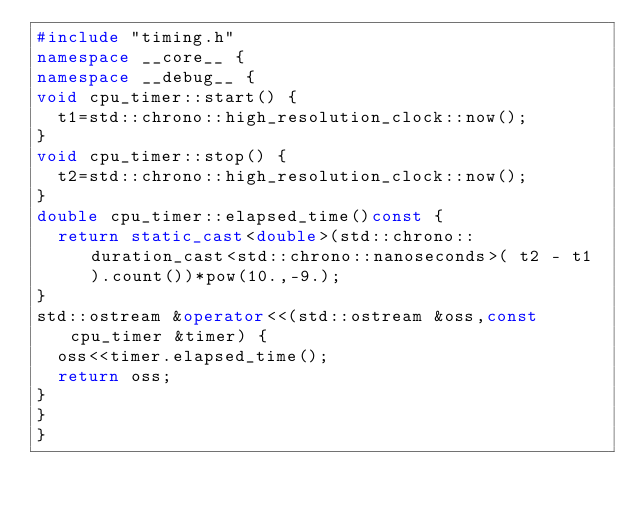Convert code to text. <code><loc_0><loc_0><loc_500><loc_500><_C++_>#include "timing.h"
namespace __core__ {
namespace __debug__ {
void cpu_timer::start() {
	t1=std::chrono::high_resolution_clock::now();
}
void cpu_timer::stop() {
	t2=std::chrono::high_resolution_clock::now();
}
double cpu_timer::elapsed_time()const {
	return static_cast<double>(std::chrono::duration_cast<std::chrono::nanoseconds>( t2 - t1 ).count())*pow(10.,-9.);
}
std::ostream &operator<<(std::ostream &oss,const cpu_timer &timer) {
	oss<<timer.elapsed_time();
	return oss;
}
}
}
</code> 